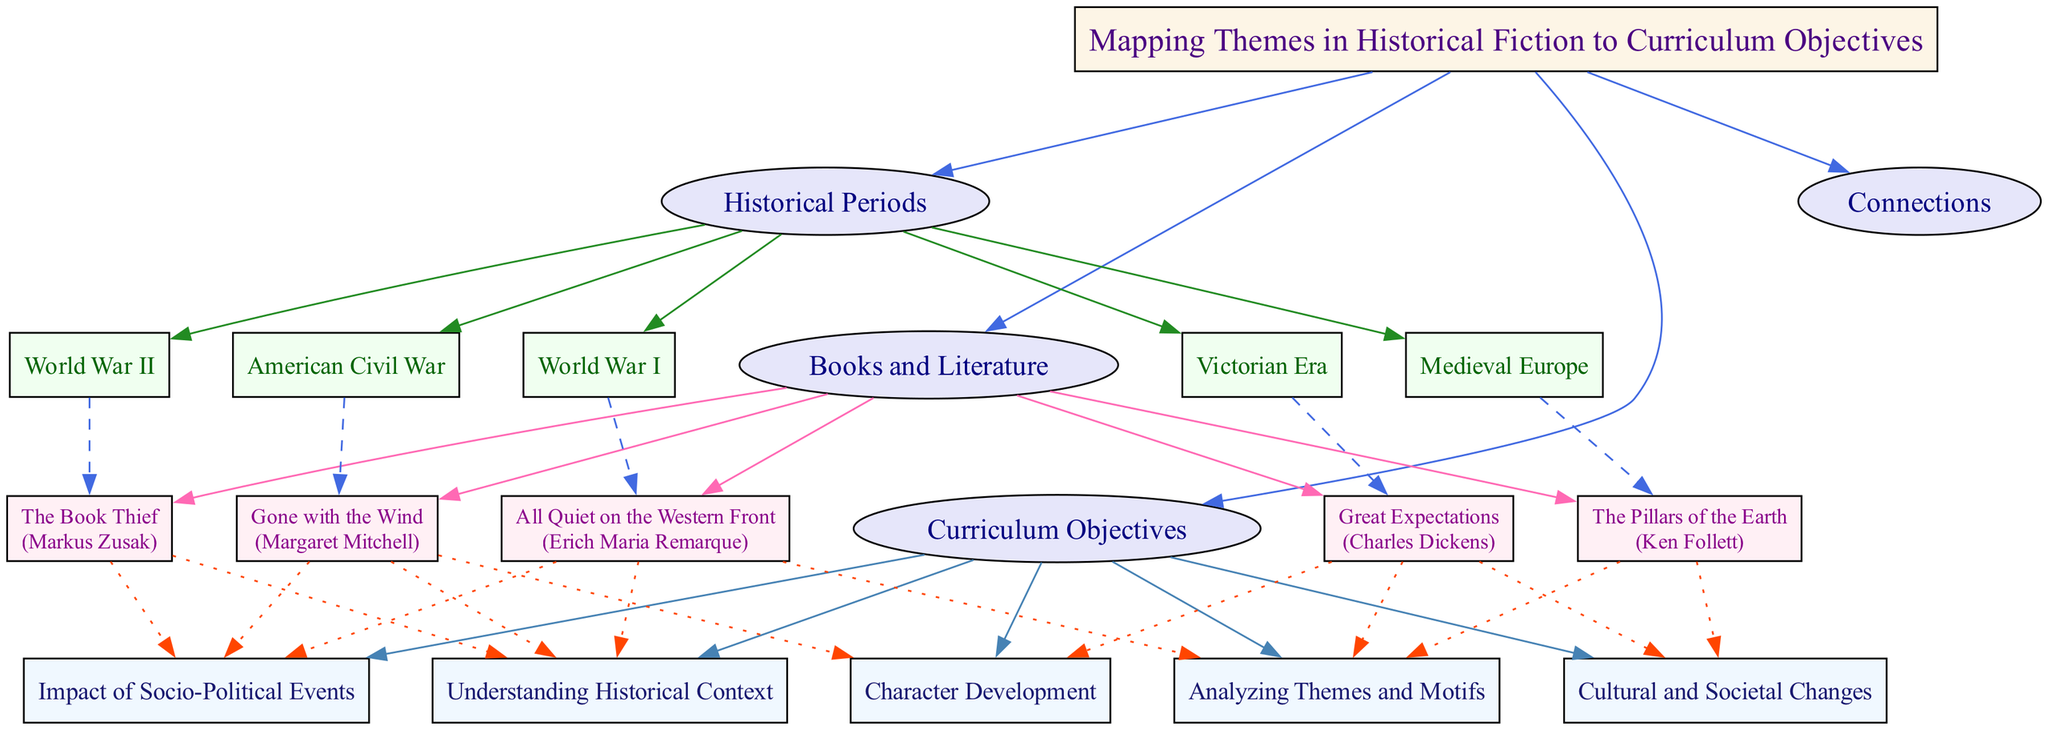What is the central theme of the concept map? The central theme is clearly stated at the top of the diagram as "Mapping Themes in Historical Fiction to Curriculum Objectives."
Answer: Mapping Themes in Historical Fiction to Curriculum Objectives How many historical periods are listed in the diagram? By counting the items listed under the "Historical Periods" category, we find there are five time periods: World War I, World War II, American Civil War, Victorian Era, and Medieval Europe.
Answer: 5 Which book is associated with the theme of the American Civil War? In the "Books and Literature" section, "Gone with the Wind" by Margaret Mitchell is identified as the book linked to the theme of the American Civil War.
Answer: Gone with the Wind Which curriculum objective is related to character development? The diagram indicates that "Character Development" is one of the curriculum objectives, connected explicitly to "Gone with the Wind" and "Great Expectations."
Answer: Character Development Which theme is connected to the most curriculum objectives? To determine this, we review all connections from the "Connections" category. "All Quiet on the Western Front," "The Book Thief," and "Gone with the Wind" are all linked to "Understanding Historical Context" and "Impact of Socio-Political Events," showing that these themes are associated with multiple objectives.
Answer: All Quiet on the Western Front How many books are listed under the "Books and Literature" category? Counting the items provides the total number of books, which are five: "All Quiet on the Western Front," "The Book Thief," "Gone with the Wind," "Great Expectations," and "The Pillars of the Earth."
Answer: 5 Which author is associated with the theme of World War II? By examining the "Books and Literature" section, "The Book Thief" by Markus Zusak is identified as connected to the theme of World War II.
Answer: Markus Zusak What is the primary connection of "The Pillars of the Earth"? Analyzing the "Connections" category for "The Pillars of the Earth," it is associated with the curriculum objective "Cultural and Societal Changes."
Answer: Cultural and Societal Changes How many books are associated with the curriculum objective of "Analyzing Themes and Motifs"? The items listed under this objective include "All Quiet on the Western Front," "Great Expectations," and "The Pillars of the Earth." Therefore, the total is three books related to this objective.
Answer: 3 